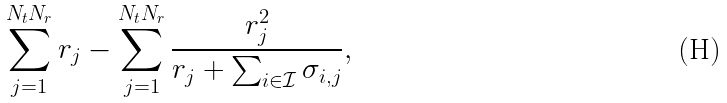<formula> <loc_0><loc_0><loc_500><loc_500>\sum _ { j = 1 } ^ { N _ { t } N _ { r } } r _ { j } - \sum _ { j = 1 } ^ { N _ { t } N _ { r } } \frac { r _ { j } ^ { 2 } } { r _ { j } + \sum _ { i \in \mathcal { I } } \sigma _ { i , j } } ,</formula> 